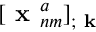<formula> <loc_0><loc_0><loc_500><loc_500>[ x _ { n m } ^ { a } ] _ { ; k }</formula> 